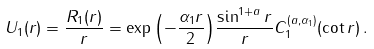<formula> <loc_0><loc_0><loc_500><loc_500>U _ { 1 } ( r ) = \frac { R _ { 1 } ( r ) } { r } = \exp { \left ( - \frac { \alpha _ { 1 } r } { 2 } \right ) } \frac { \sin ^ { 1 + a } r } { r } C ^ { ( a , \alpha _ { 1 } ) } _ { 1 } ( \cot r ) \, .</formula> 